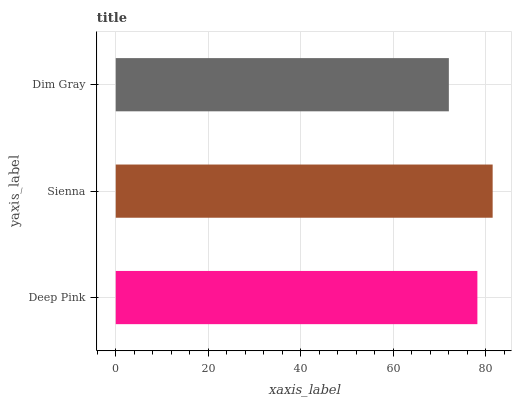Is Dim Gray the minimum?
Answer yes or no. Yes. Is Sienna the maximum?
Answer yes or no. Yes. Is Sienna the minimum?
Answer yes or no. No. Is Dim Gray the maximum?
Answer yes or no. No. Is Sienna greater than Dim Gray?
Answer yes or no. Yes. Is Dim Gray less than Sienna?
Answer yes or no. Yes. Is Dim Gray greater than Sienna?
Answer yes or no. No. Is Sienna less than Dim Gray?
Answer yes or no. No. Is Deep Pink the high median?
Answer yes or no. Yes. Is Deep Pink the low median?
Answer yes or no. Yes. Is Sienna the high median?
Answer yes or no. No. Is Dim Gray the low median?
Answer yes or no. No. 